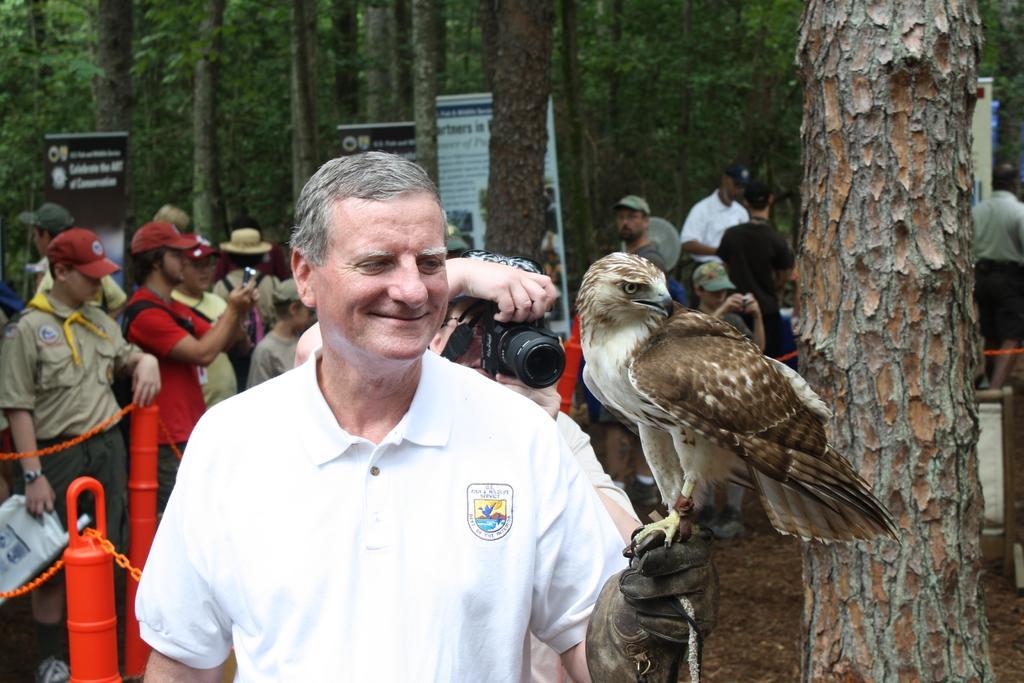Can you describe this image briefly? This is the man standing and smiling. I can see an eagle standing on a person's hand. Here is a person holding a camera and clicking pictures. There are group of people standing. This looks like a tree trunk. I can see the boards. I think these are the kind of barricades. I can see the trees. 